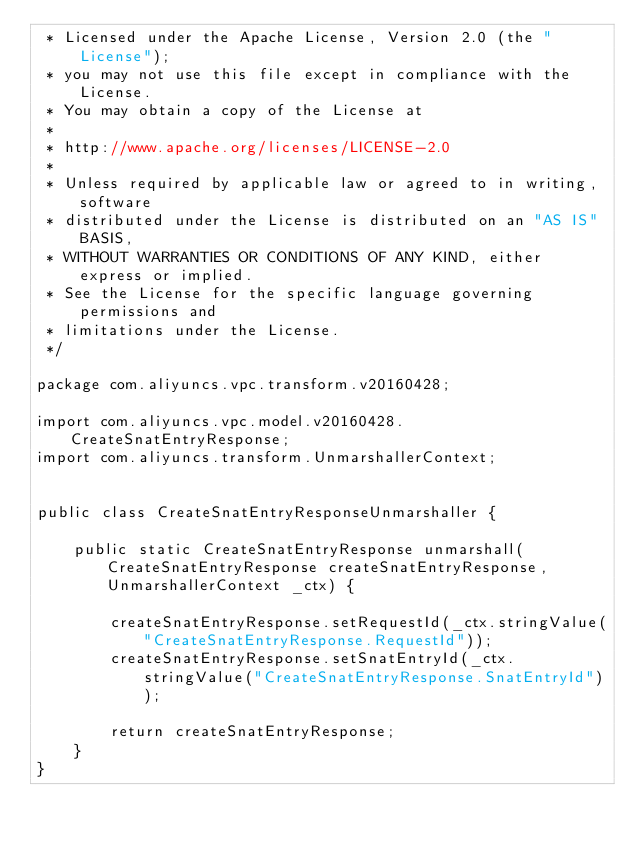Convert code to text. <code><loc_0><loc_0><loc_500><loc_500><_Java_> * Licensed under the Apache License, Version 2.0 (the "License");
 * you may not use this file except in compliance with the License.
 * You may obtain a copy of the License at
 *
 * http://www.apache.org/licenses/LICENSE-2.0
 *
 * Unless required by applicable law or agreed to in writing, software
 * distributed under the License is distributed on an "AS IS" BASIS,
 * WITHOUT WARRANTIES OR CONDITIONS OF ANY KIND, either express or implied.
 * See the License for the specific language governing permissions and
 * limitations under the License.
 */

package com.aliyuncs.vpc.transform.v20160428;

import com.aliyuncs.vpc.model.v20160428.CreateSnatEntryResponse;
import com.aliyuncs.transform.UnmarshallerContext;


public class CreateSnatEntryResponseUnmarshaller {

	public static CreateSnatEntryResponse unmarshall(CreateSnatEntryResponse createSnatEntryResponse, UnmarshallerContext _ctx) {
		
		createSnatEntryResponse.setRequestId(_ctx.stringValue("CreateSnatEntryResponse.RequestId"));
		createSnatEntryResponse.setSnatEntryId(_ctx.stringValue("CreateSnatEntryResponse.SnatEntryId"));
	 
	 	return createSnatEntryResponse;
	}
}</code> 